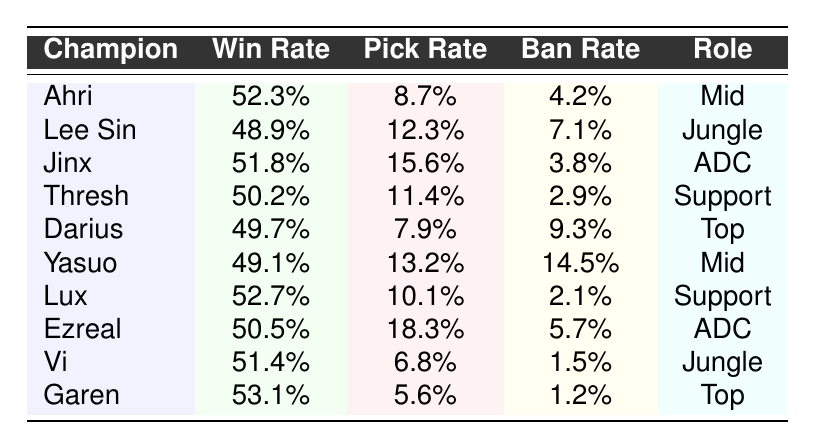What is the highest win rate among the champions? The champions listed with their win rates show that Garen has the highest win rate at 53.1%.
Answer: 53.1% Which champion has the lowest pick rate? By examining the pick rates in the table, I see that Garen has the lowest pick rate at 5.6%.
Answer: 5.6% How many champions have a win rate above 50%? From the table, Ahri, Jinx, Lux, and Garen have win rates above 50%, which makes a total of four champions.
Answer: 4 What is the win rate difference between Jinx and Lee Sin? Jinx has a win rate of 51.8% and Lee Sin has 48.9%. The difference is calculated as 51.8% - 48.9% = 2.9%.
Answer: 2.9% Is Thresh more frequently picked than Garen? Thresh has a pick rate of 11.4%, while Garen has a pick rate of 5.6%. Since 11.4% is greater than 5.6%, the statement is true.
Answer: Yes What is the average win rate of champions in the Support role? Analyzing the win rates for Support champions (Thresh and Lux) gives 50.2% + 52.7% = 102.9%. Dividing by 2, the average win rate is 102.9% / 2 = 51.45%.
Answer: 51.45% Which champion has the highest ban rate, and what is it? Looking at the ban rates, Yasuo has the highest ban rate of 14.5%.
Answer: 14.5% How does the win rate of Vi compare to that of Darius? Vi has a win rate of 51.4%, whereas Darius has 49.7%. Therefore, Vi has a higher win rate than Darius.
Answer: Vi has a higher win rate What is the total pick rate of champions in the ADC role? Jinx has a pick rate of 15.6% and Ezreal has 18.3%. Summing them results in 15.6% + 18.3% = 33.9%.
Answer: 33.9% Is there any champion with a win rate below 50%? Both Lee Sin (48.9%) and Yasuo (49.1%) have win rates below 50%, indicating this statement is true.
Answer: Yes 